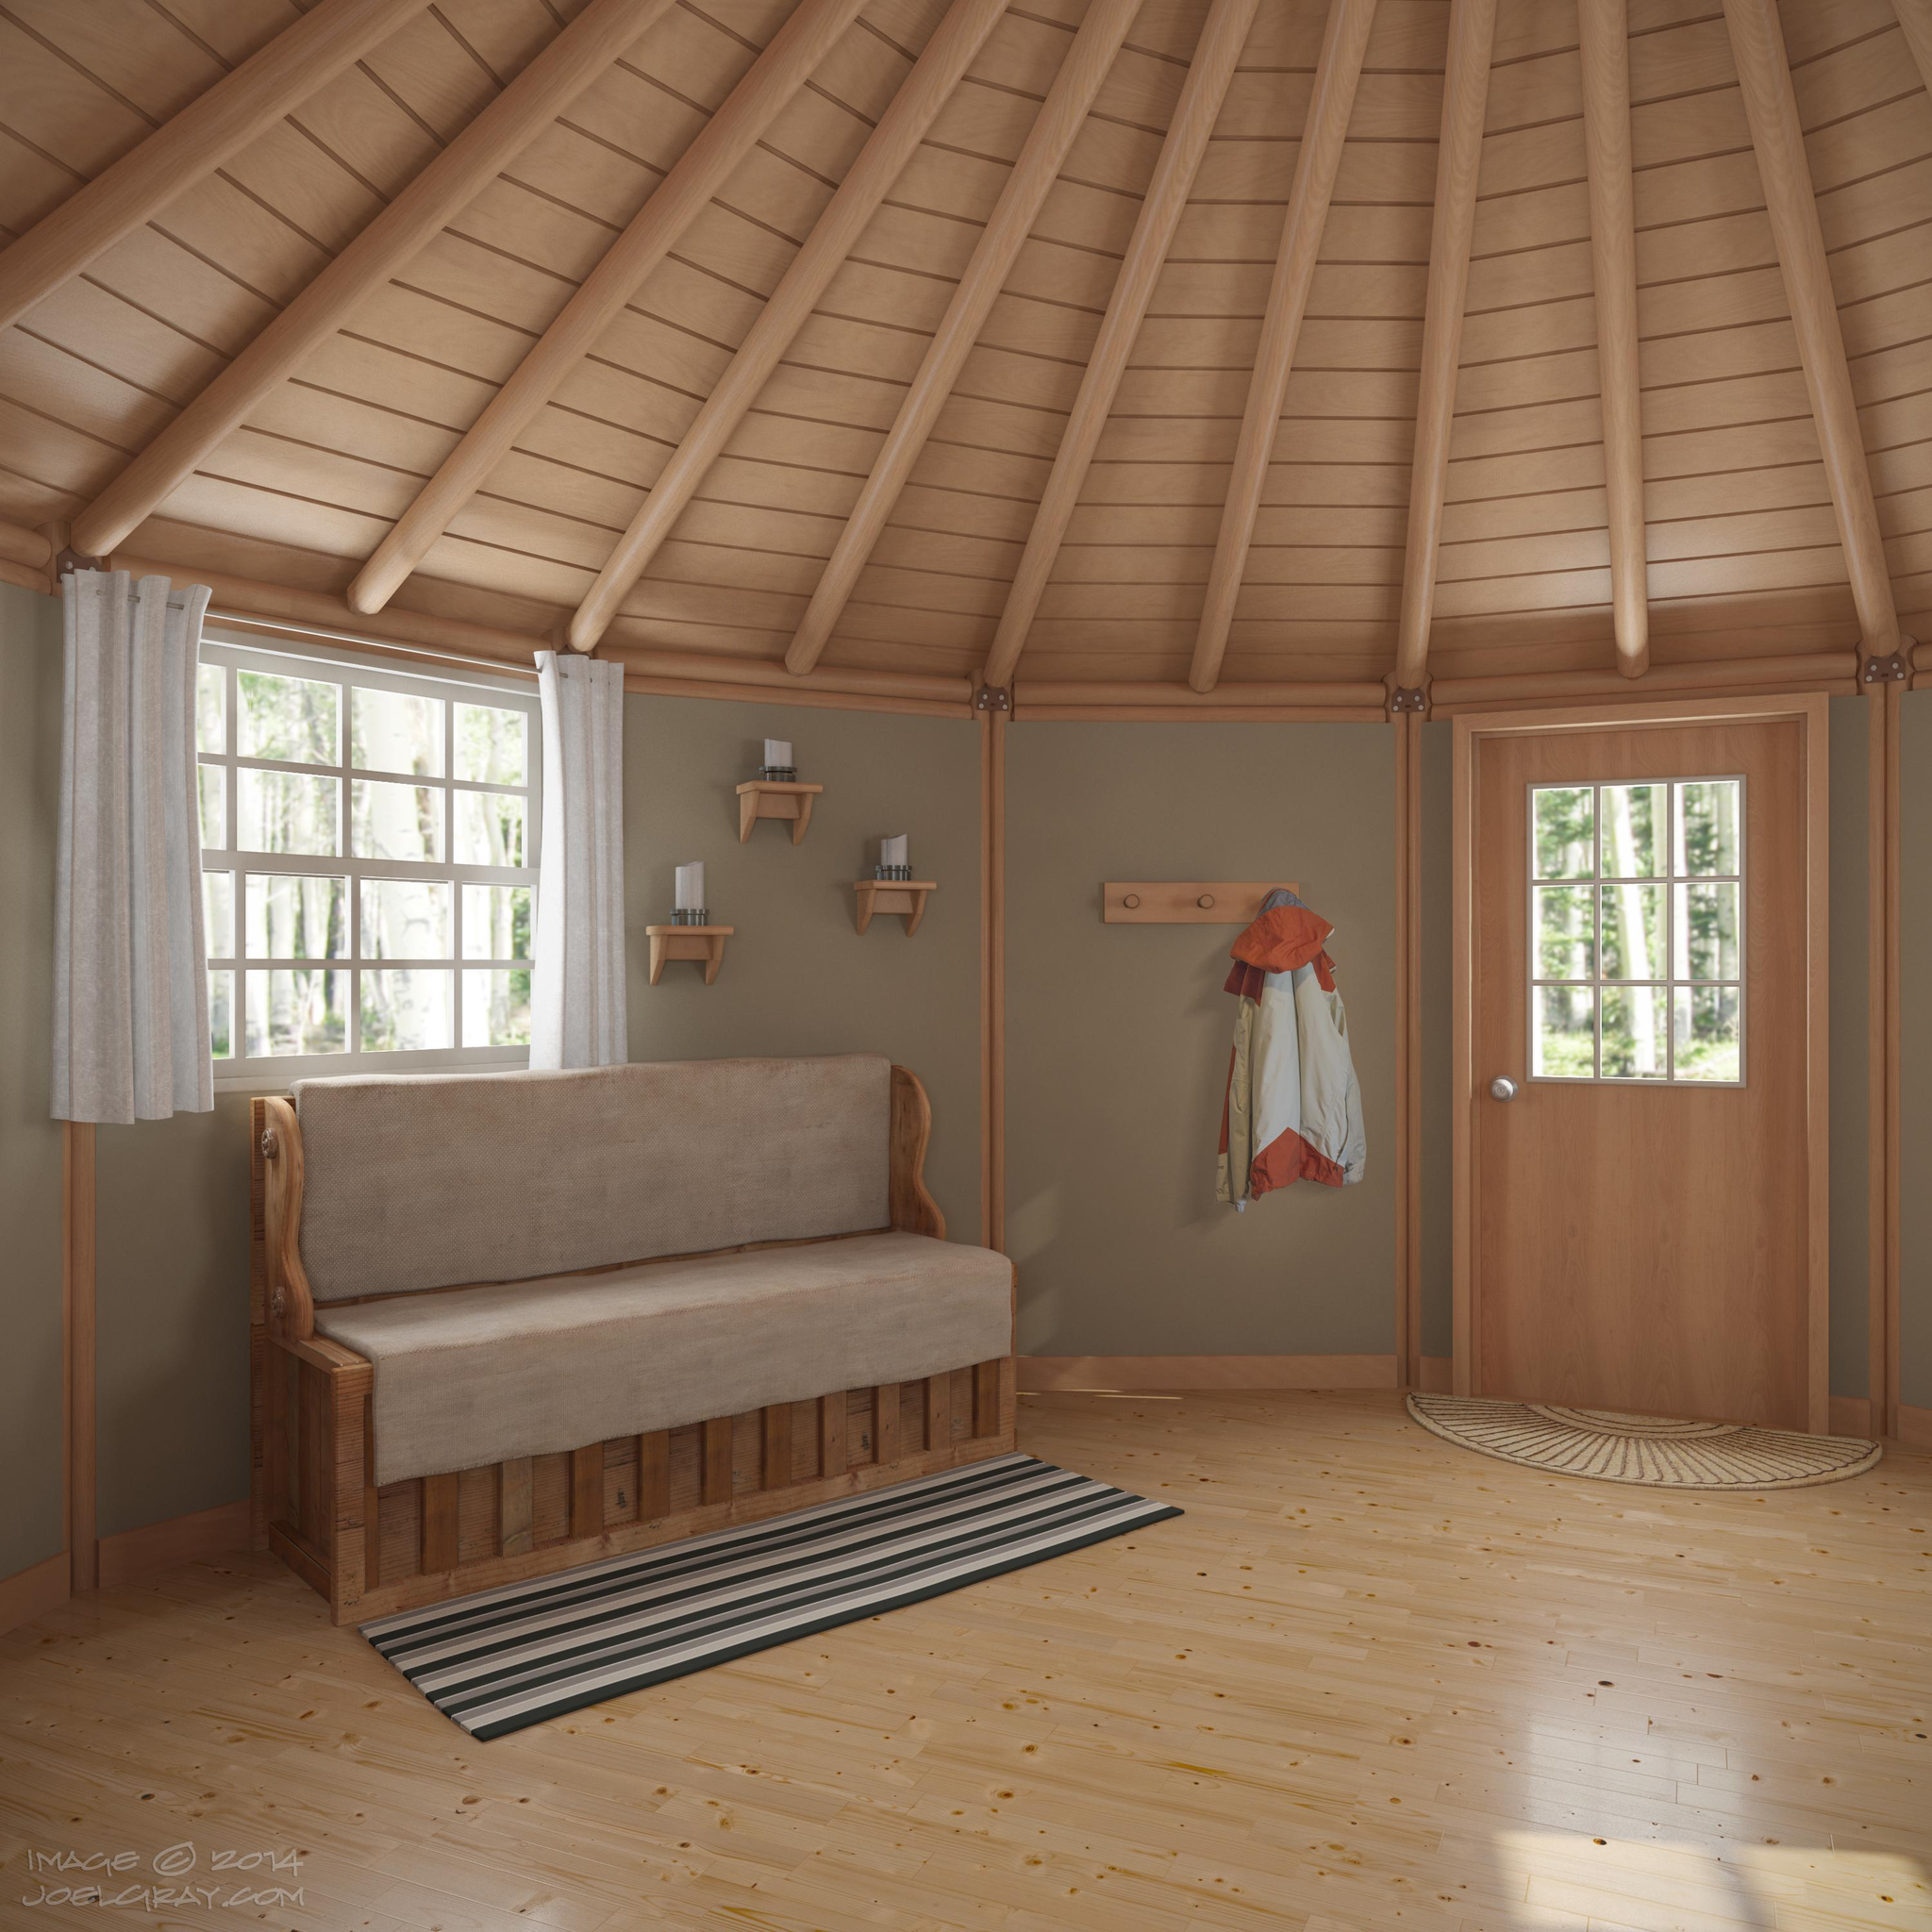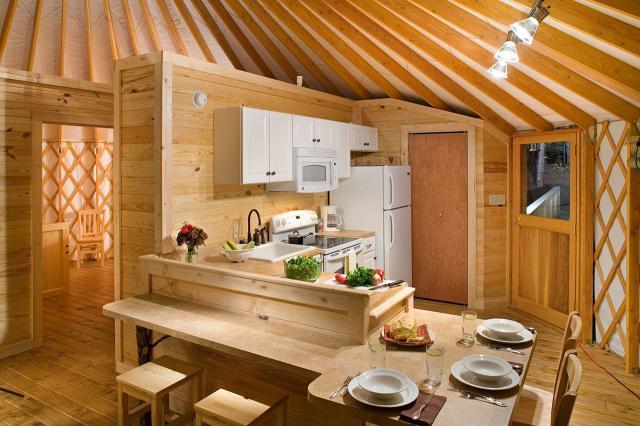The first image is the image on the left, the second image is the image on the right. Analyze the images presented: Is the assertion "One image shows the kitchen of a yurt with white refrigerator and microwave, near a dining seating area with wooden kitchen chairs." valid? Answer yes or no. Yes. The first image is the image on the left, the second image is the image on the right. Analyze the images presented: Is the assertion "An image shows a sky-light type many-sided element at the peak of a room's ceiling." valid? Answer yes or no. No. 